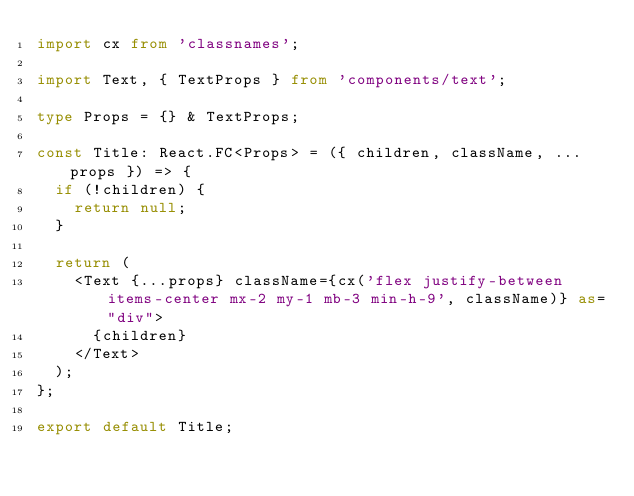Convert code to text. <code><loc_0><loc_0><loc_500><loc_500><_TypeScript_>import cx from 'classnames';

import Text, { TextProps } from 'components/text';

type Props = {} & TextProps;

const Title: React.FC<Props> = ({ children, className, ...props }) => {
  if (!children) {
    return null;
  }

  return (
    <Text {...props} className={cx('flex justify-between items-center mx-2 my-1 mb-3 min-h-9', className)} as="div">
      {children}
    </Text>
  );
};

export default Title;
</code> 